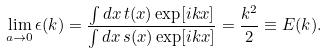Convert formula to latex. <formula><loc_0><loc_0><loc_500><loc_500>\lim _ { a \rightarrow 0 } \epsilon ( k ) = \frac { \int d x \, t ( x ) \exp [ i k x ] } { \int d x \, s ( x ) \exp [ i k x ] } = \frac { k ^ { 2 } } { 2 } \equiv E ( k ) .</formula> 